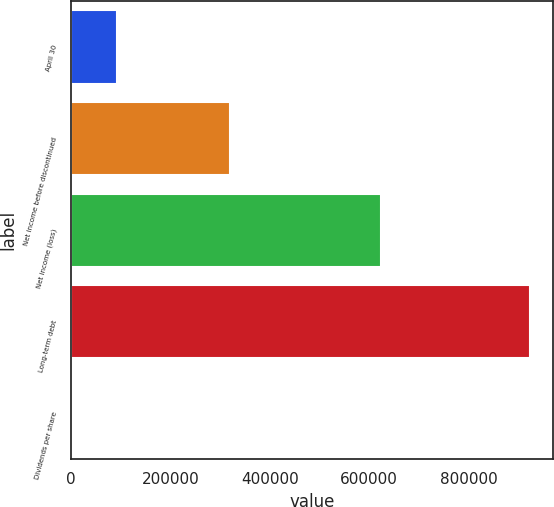Convert chart to OTSL. <chart><loc_0><loc_0><loc_500><loc_500><bar_chart><fcel>April 30<fcel>Net income before discontinued<fcel>Net income (loss)<fcel>Long-term debt<fcel>Dividends per share<nl><fcel>92293.7<fcel>319749<fcel>623910<fcel>922933<fcel>0.43<nl></chart> 